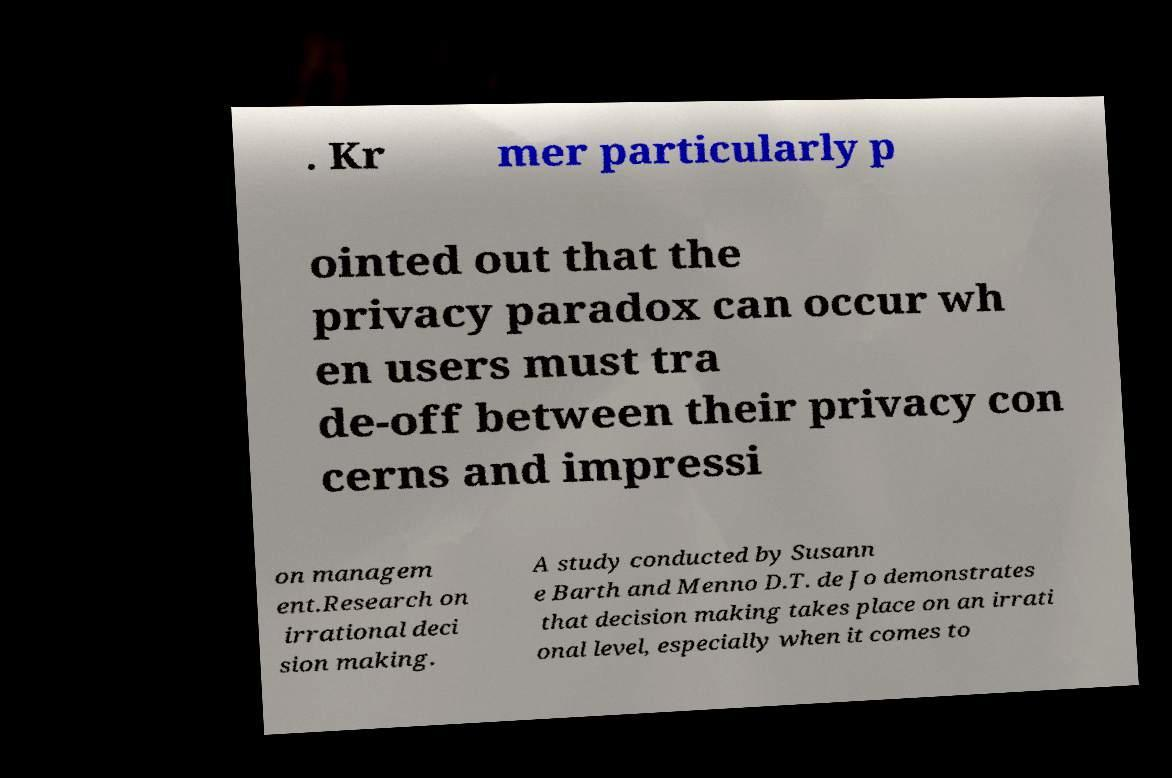Can you read and provide the text displayed in the image?This photo seems to have some interesting text. Can you extract and type it out for me? . Kr mer particularly p ointed out that the privacy paradox can occur wh en users must tra de-off between their privacy con cerns and impressi on managem ent.Research on irrational deci sion making. A study conducted by Susann e Barth and Menno D.T. de Jo demonstrates that decision making takes place on an irrati onal level, especially when it comes to 